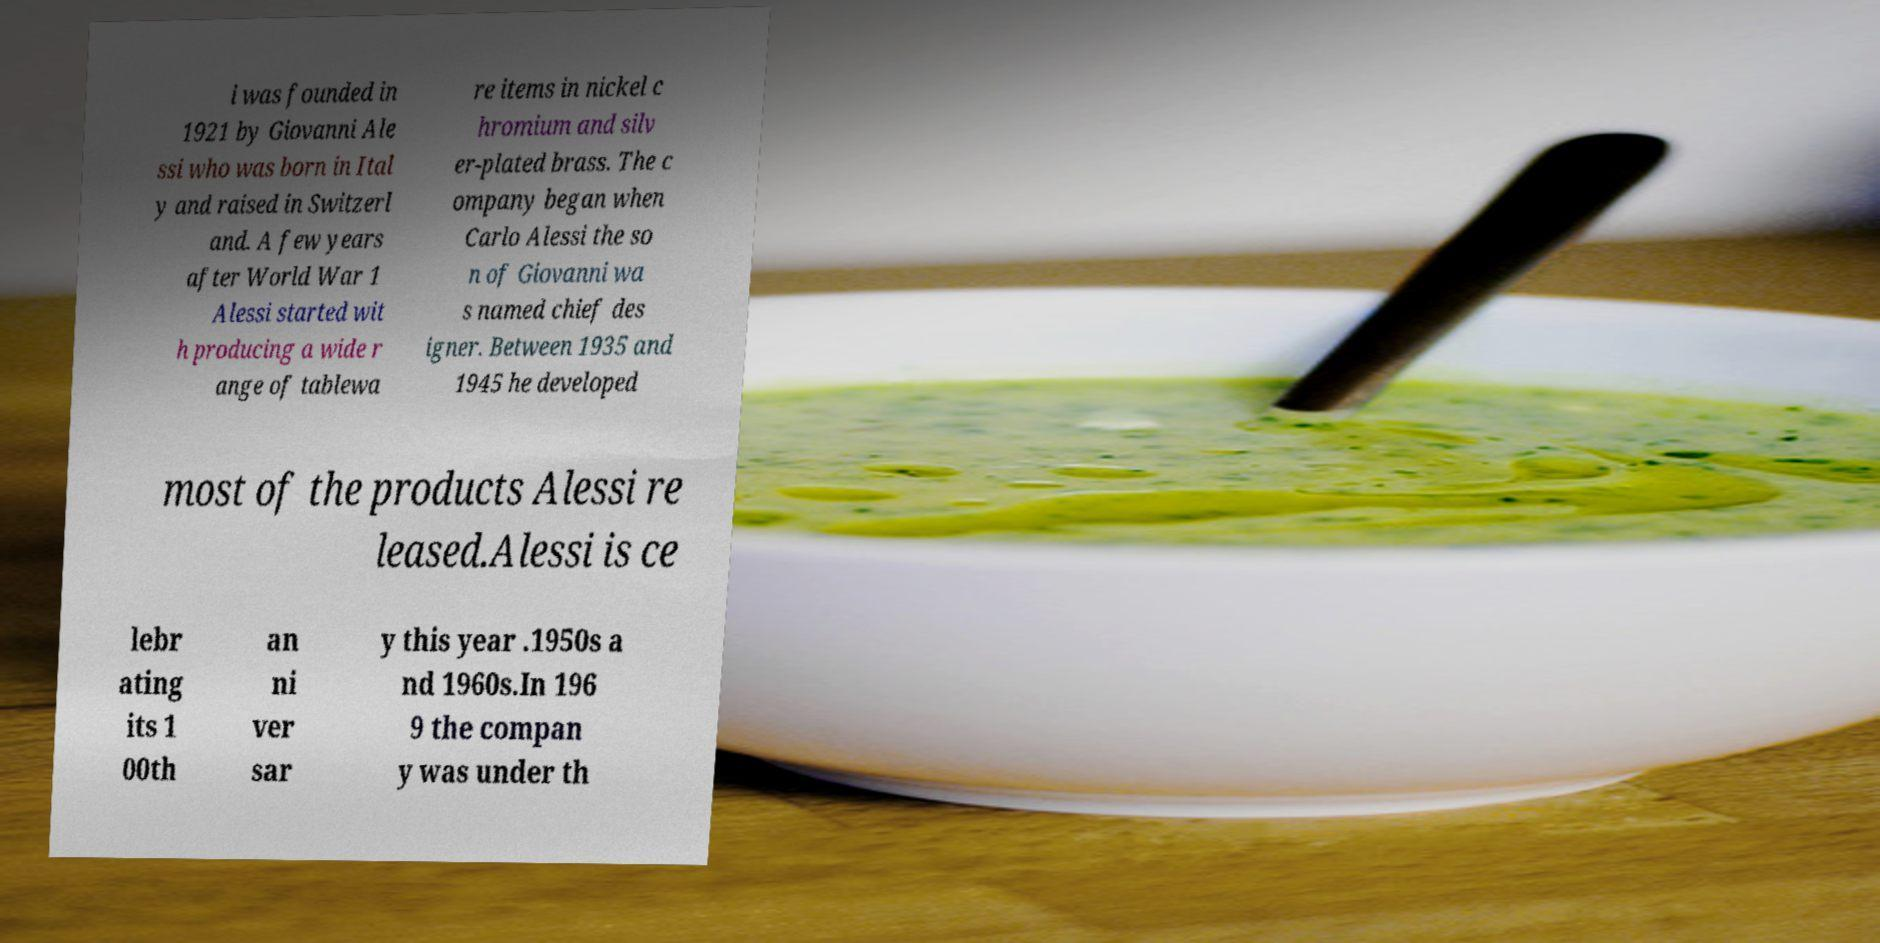What messages or text are displayed in this image? I need them in a readable, typed format. i was founded in 1921 by Giovanni Ale ssi who was born in Ital y and raised in Switzerl and. A few years after World War 1 Alessi started wit h producing a wide r ange of tablewa re items in nickel c hromium and silv er-plated brass. The c ompany began when Carlo Alessi the so n of Giovanni wa s named chief des igner. Between 1935 and 1945 he developed most of the products Alessi re leased.Alessi is ce lebr ating its 1 00th an ni ver sar y this year .1950s a nd 1960s.In 196 9 the compan y was under th 